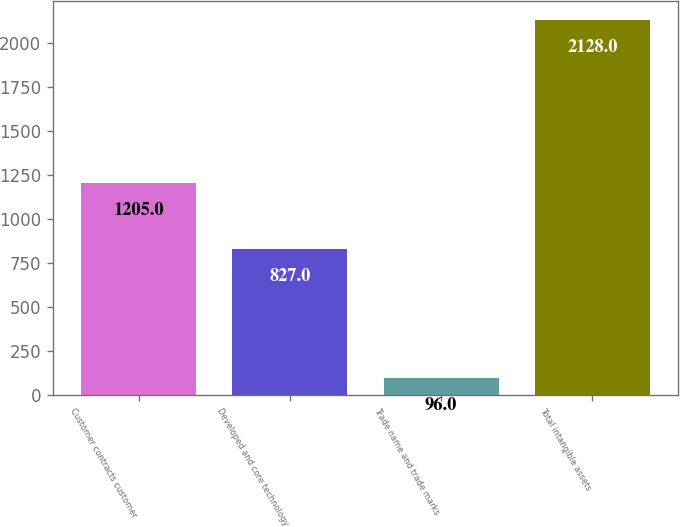<chart> <loc_0><loc_0><loc_500><loc_500><bar_chart><fcel>Customer contracts customer<fcel>Developed and core technology<fcel>Trade name and trade marks<fcel>Total intangible assets<nl><fcel>1205<fcel>827<fcel>96<fcel>2128<nl></chart> 